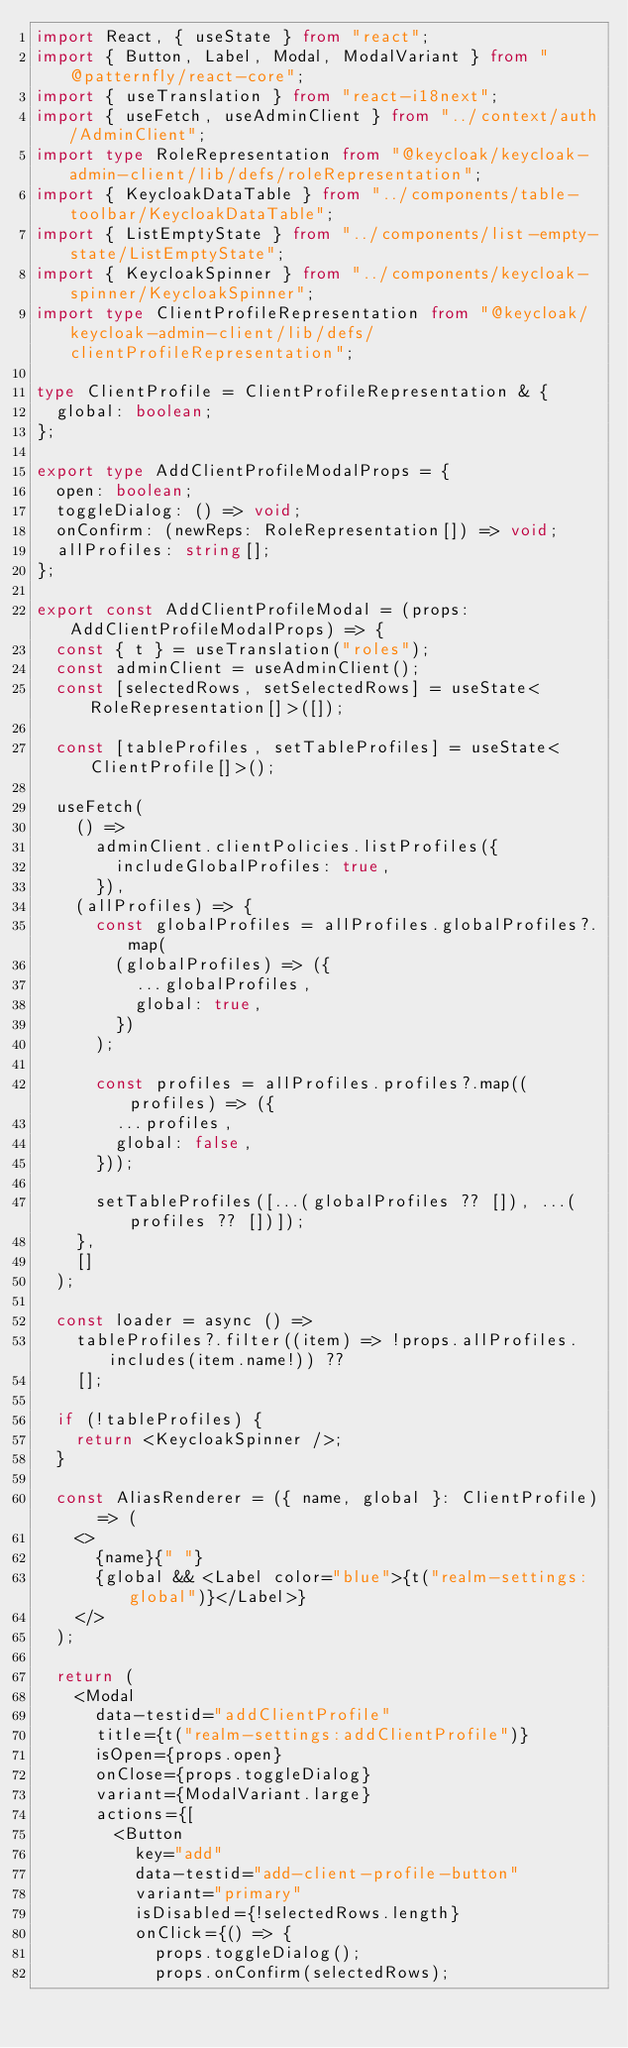<code> <loc_0><loc_0><loc_500><loc_500><_TypeScript_>import React, { useState } from "react";
import { Button, Label, Modal, ModalVariant } from "@patternfly/react-core";
import { useTranslation } from "react-i18next";
import { useFetch, useAdminClient } from "../context/auth/AdminClient";
import type RoleRepresentation from "@keycloak/keycloak-admin-client/lib/defs/roleRepresentation";
import { KeycloakDataTable } from "../components/table-toolbar/KeycloakDataTable";
import { ListEmptyState } from "../components/list-empty-state/ListEmptyState";
import { KeycloakSpinner } from "../components/keycloak-spinner/KeycloakSpinner";
import type ClientProfileRepresentation from "@keycloak/keycloak-admin-client/lib/defs/clientProfileRepresentation";

type ClientProfile = ClientProfileRepresentation & {
  global: boolean;
};

export type AddClientProfileModalProps = {
  open: boolean;
  toggleDialog: () => void;
  onConfirm: (newReps: RoleRepresentation[]) => void;
  allProfiles: string[];
};

export const AddClientProfileModal = (props: AddClientProfileModalProps) => {
  const { t } = useTranslation("roles");
  const adminClient = useAdminClient();
  const [selectedRows, setSelectedRows] = useState<RoleRepresentation[]>([]);

  const [tableProfiles, setTableProfiles] = useState<ClientProfile[]>();

  useFetch(
    () =>
      adminClient.clientPolicies.listProfiles({
        includeGlobalProfiles: true,
      }),
    (allProfiles) => {
      const globalProfiles = allProfiles.globalProfiles?.map(
        (globalProfiles) => ({
          ...globalProfiles,
          global: true,
        })
      );

      const profiles = allProfiles.profiles?.map((profiles) => ({
        ...profiles,
        global: false,
      }));

      setTableProfiles([...(globalProfiles ?? []), ...(profiles ?? [])]);
    },
    []
  );

  const loader = async () =>
    tableProfiles?.filter((item) => !props.allProfiles.includes(item.name!)) ??
    [];

  if (!tableProfiles) {
    return <KeycloakSpinner />;
  }

  const AliasRenderer = ({ name, global }: ClientProfile) => (
    <>
      {name}{" "}
      {global && <Label color="blue">{t("realm-settings:global")}</Label>}
    </>
  );

  return (
    <Modal
      data-testid="addClientProfile"
      title={t("realm-settings:addClientProfile")}
      isOpen={props.open}
      onClose={props.toggleDialog}
      variant={ModalVariant.large}
      actions={[
        <Button
          key="add"
          data-testid="add-client-profile-button"
          variant="primary"
          isDisabled={!selectedRows.length}
          onClick={() => {
            props.toggleDialog();
            props.onConfirm(selectedRows);</code> 